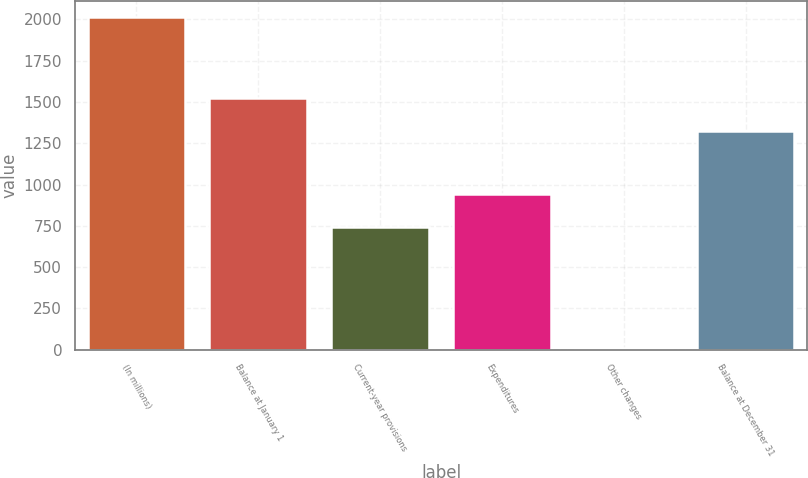Convert chart. <chart><loc_0><loc_0><loc_500><loc_500><bar_chart><fcel>(In millions)<fcel>Balance at January 1<fcel>Current-year provisions<fcel>Expenditures<fcel>Other changes<fcel>Balance at December 31<nl><fcel>2013<fcel>1524.3<fcel>745<fcel>945.3<fcel>10<fcel>1324<nl></chart> 